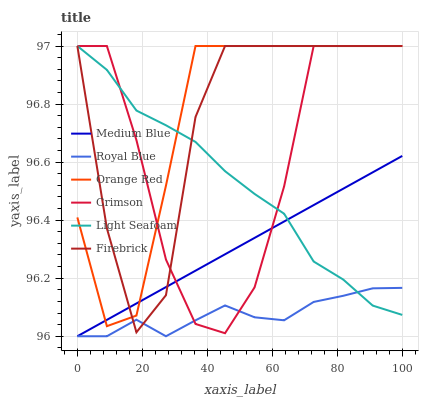Does Royal Blue have the minimum area under the curve?
Answer yes or no. Yes. Does Orange Red have the maximum area under the curve?
Answer yes or no. Yes. Does Medium Blue have the minimum area under the curve?
Answer yes or no. No. Does Medium Blue have the maximum area under the curve?
Answer yes or no. No. Is Medium Blue the smoothest?
Answer yes or no. Yes. Is Firebrick the roughest?
Answer yes or no. Yes. Is Royal Blue the smoothest?
Answer yes or no. No. Is Royal Blue the roughest?
Answer yes or no. No. Does Medium Blue have the lowest value?
Answer yes or no. Yes. Does Crimson have the lowest value?
Answer yes or no. No. Does Orange Red have the highest value?
Answer yes or no. Yes. Does Medium Blue have the highest value?
Answer yes or no. No. Is Royal Blue less than Orange Red?
Answer yes or no. Yes. Is Orange Red greater than Royal Blue?
Answer yes or no. Yes. Does Firebrick intersect Orange Red?
Answer yes or no. Yes. Is Firebrick less than Orange Red?
Answer yes or no. No. Is Firebrick greater than Orange Red?
Answer yes or no. No. Does Royal Blue intersect Orange Red?
Answer yes or no. No. 